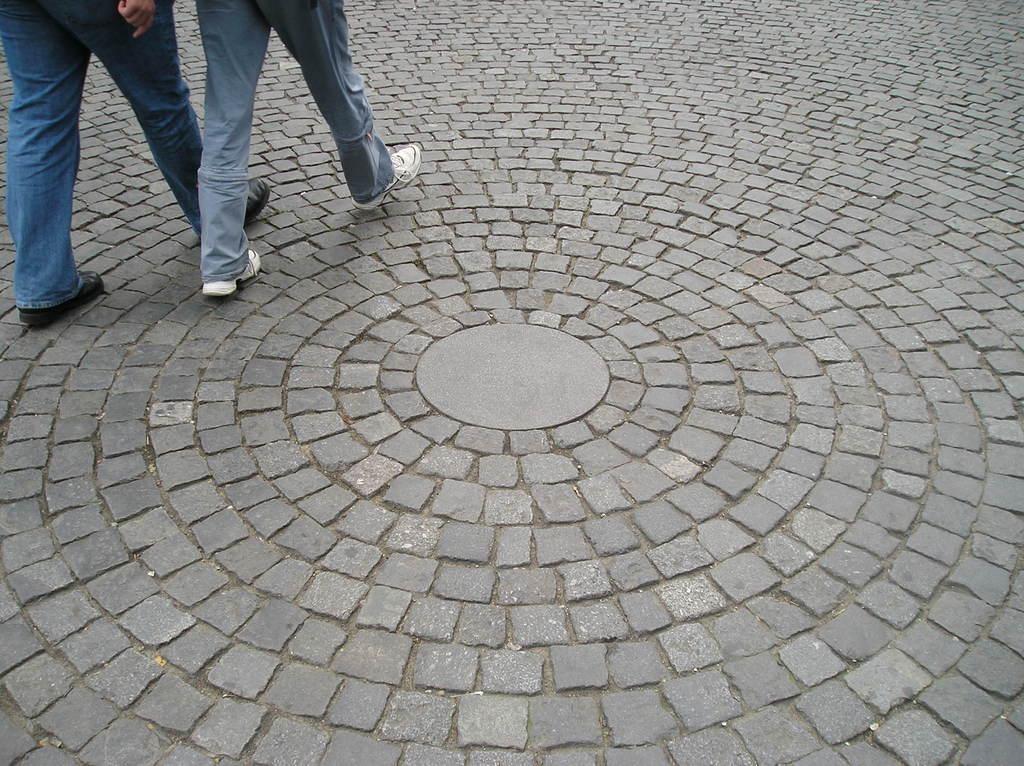Please provide a concise description of this image. In this image I can see two people are walking on the grey color surface. 